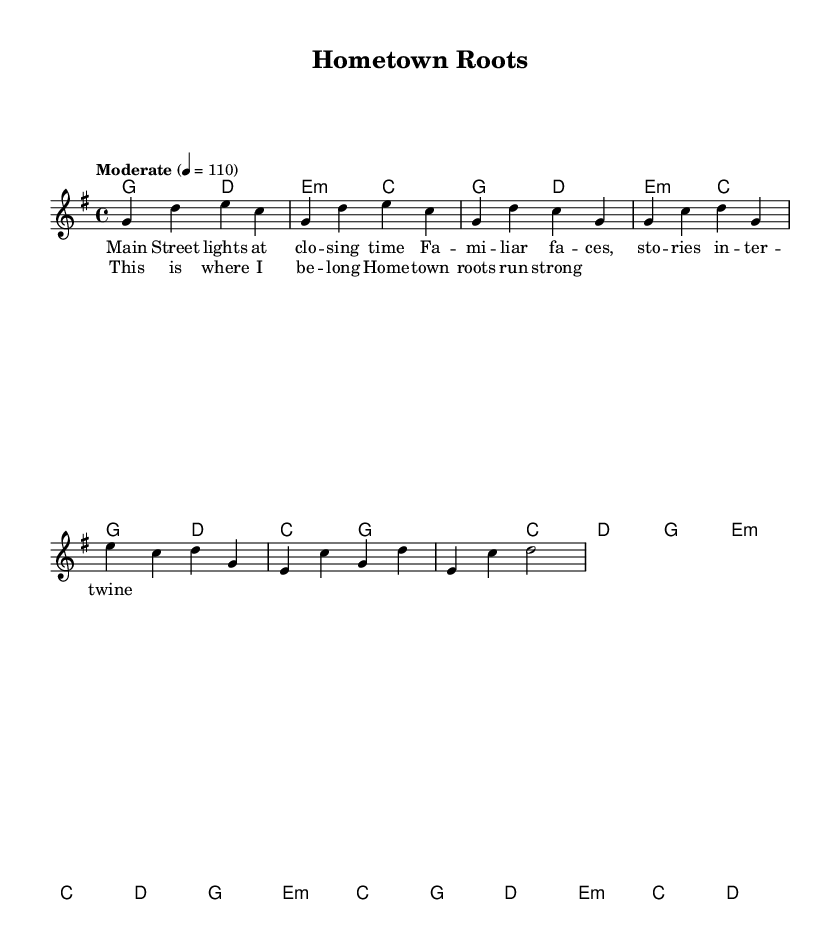What is the key signature of this music? The key signature is G major, which has one sharp (F#). This is determined by looking at the key signature indicated on the staff, which matches the notes specified in the melody and harmonies.
Answer: G major What is the time signature of this music? The time signature is 4/4, indicated at the beginning of the score. This means there are four beats in a measure and the quarter note gets one beat.
Answer: 4/4 What is the tempo marking for this piece? The tempo marking is "Moderate" set at 110 beats per minute. This can be found in the section that indicates the speed of the music, typically listed at the beginning.
Answer: Moderate 110 How many measures are in the verse? There are four measures in the verse. This is determined by counting the measures in the melody and harmonies sections that contain the lyric part for the verse.
Answer: Four What emotions or themes does the chorus convey? The chorus conveys a sense of belonging and strong community ties, emphasized by the lyrics "This is where I belong" and "Hometown roots run strong." This resonates with the theme of small-town life and community values prominent in country rock music.
Answer: Belonging and community What chord is used in the bridge section? The bridge section primarily uses the e minor chord and c major chord, as indicated in the harmonies section. Each section of the bridge has these chords played in sequence.
Answer: E minor and C major 